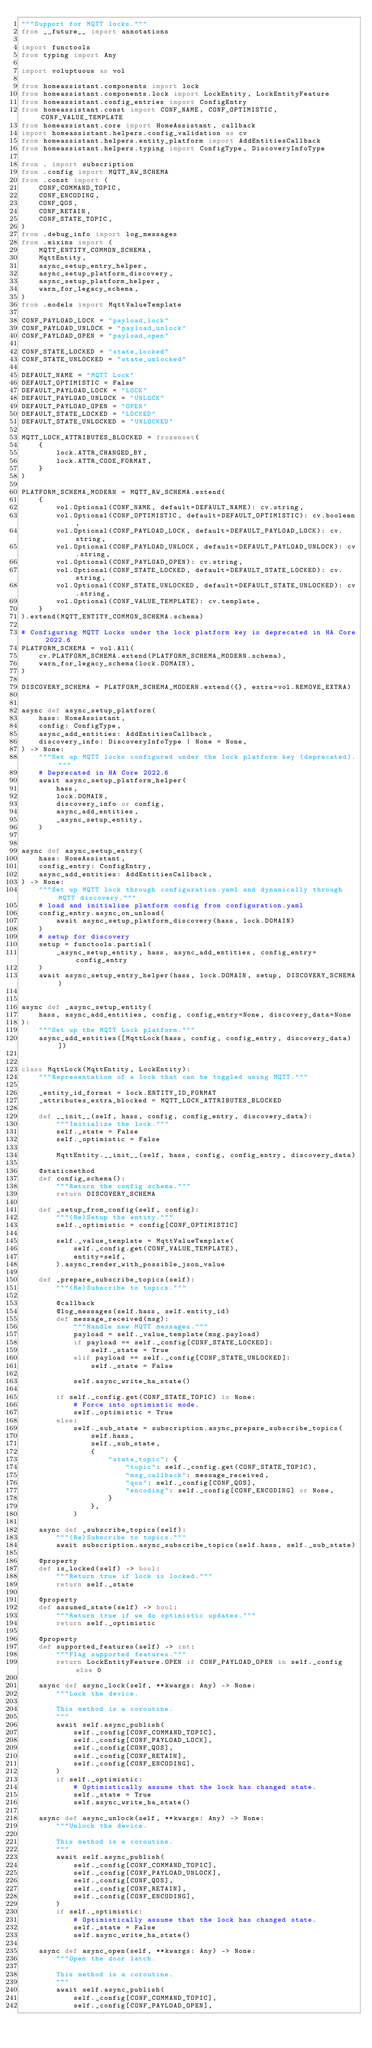Convert code to text. <code><loc_0><loc_0><loc_500><loc_500><_Python_>"""Support for MQTT locks."""
from __future__ import annotations

import functools
from typing import Any

import voluptuous as vol

from homeassistant.components import lock
from homeassistant.components.lock import LockEntity, LockEntityFeature
from homeassistant.config_entries import ConfigEntry
from homeassistant.const import CONF_NAME, CONF_OPTIMISTIC, CONF_VALUE_TEMPLATE
from homeassistant.core import HomeAssistant, callback
import homeassistant.helpers.config_validation as cv
from homeassistant.helpers.entity_platform import AddEntitiesCallback
from homeassistant.helpers.typing import ConfigType, DiscoveryInfoType

from . import subscription
from .config import MQTT_RW_SCHEMA
from .const import (
    CONF_COMMAND_TOPIC,
    CONF_ENCODING,
    CONF_QOS,
    CONF_RETAIN,
    CONF_STATE_TOPIC,
)
from .debug_info import log_messages
from .mixins import (
    MQTT_ENTITY_COMMON_SCHEMA,
    MqttEntity,
    async_setup_entry_helper,
    async_setup_platform_discovery,
    async_setup_platform_helper,
    warn_for_legacy_schema,
)
from .models import MqttValueTemplate

CONF_PAYLOAD_LOCK = "payload_lock"
CONF_PAYLOAD_UNLOCK = "payload_unlock"
CONF_PAYLOAD_OPEN = "payload_open"

CONF_STATE_LOCKED = "state_locked"
CONF_STATE_UNLOCKED = "state_unlocked"

DEFAULT_NAME = "MQTT Lock"
DEFAULT_OPTIMISTIC = False
DEFAULT_PAYLOAD_LOCK = "LOCK"
DEFAULT_PAYLOAD_UNLOCK = "UNLOCK"
DEFAULT_PAYLOAD_OPEN = "OPEN"
DEFAULT_STATE_LOCKED = "LOCKED"
DEFAULT_STATE_UNLOCKED = "UNLOCKED"

MQTT_LOCK_ATTRIBUTES_BLOCKED = frozenset(
    {
        lock.ATTR_CHANGED_BY,
        lock.ATTR_CODE_FORMAT,
    }
)

PLATFORM_SCHEMA_MODERN = MQTT_RW_SCHEMA.extend(
    {
        vol.Optional(CONF_NAME, default=DEFAULT_NAME): cv.string,
        vol.Optional(CONF_OPTIMISTIC, default=DEFAULT_OPTIMISTIC): cv.boolean,
        vol.Optional(CONF_PAYLOAD_LOCK, default=DEFAULT_PAYLOAD_LOCK): cv.string,
        vol.Optional(CONF_PAYLOAD_UNLOCK, default=DEFAULT_PAYLOAD_UNLOCK): cv.string,
        vol.Optional(CONF_PAYLOAD_OPEN): cv.string,
        vol.Optional(CONF_STATE_LOCKED, default=DEFAULT_STATE_LOCKED): cv.string,
        vol.Optional(CONF_STATE_UNLOCKED, default=DEFAULT_STATE_UNLOCKED): cv.string,
        vol.Optional(CONF_VALUE_TEMPLATE): cv.template,
    }
).extend(MQTT_ENTITY_COMMON_SCHEMA.schema)

# Configuring MQTT Locks under the lock platform key is deprecated in HA Core 2022.6
PLATFORM_SCHEMA = vol.All(
    cv.PLATFORM_SCHEMA.extend(PLATFORM_SCHEMA_MODERN.schema),
    warn_for_legacy_schema(lock.DOMAIN),
)

DISCOVERY_SCHEMA = PLATFORM_SCHEMA_MODERN.extend({}, extra=vol.REMOVE_EXTRA)


async def async_setup_platform(
    hass: HomeAssistant,
    config: ConfigType,
    async_add_entities: AddEntitiesCallback,
    discovery_info: DiscoveryInfoType | None = None,
) -> None:
    """Set up MQTT locks configured under the lock platform key (deprecated)."""
    # Deprecated in HA Core 2022.6
    await async_setup_platform_helper(
        hass,
        lock.DOMAIN,
        discovery_info or config,
        async_add_entities,
        _async_setup_entity,
    )


async def async_setup_entry(
    hass: HomeAssistant,
    config_entry: ConfigEntry,
    async_add_entities: AddEntitiesCallback,
) -> None:
    """Set up MQTT lock through configuration.yaml and dynamically through MQTT discovery."""
    # load and initialize platform config from configuration.yaml
    config_entry.async_on_unload(
        await async_setup_platform_discovery(hass, lock.DOMAIN)
    )
    # setup for discovery
    setup = functools.partial(
        _async_setup_entity, hass, async_add_entities, config_entry=config_entry
    )
    await async_setup_entry_helper(hass, lock.DOMAIN, setup, DISCOVERY_SCHEMA)


async def _async_setup_entity(
    hass, async_add_entities, config, config_entry=None, discovery_data=None
):
    """Set up the MQTT Lock platform."""
    async_add_entities([MqttLock(hass, config, config_entry, discovery_data)])


class MqttLock(MqttEntity, LockEntity):
    """Representation of a lock that can be toggled using MQTT."""

    _entity_id_format = lock.ENTITY_ID_FORMAT
    _attributes_extra_blocked = MQTT_LOCK_ATTRIBUTES_BLOCKED

    def __init__(self, hass, config, config_entry, discovery_data):
        """Initialize the lock."""
        self._state = False
        self._optimistic = False

        MqttEntity.__init__(self, hass, config, config_entry, discovery_data)

    @staticmethod
    def config_schema():
        """Return the config schema."""
        return DISCOVERY_SCHEMA

    def _setup_from_config(self, config):
        """(Re)Setup the entity."""
        self._optimistic = config[CONF_OPTIMISTIC]

        self._value_template = MqttValueTemplate(
            self._config.get(CONF_VALUE_TEMPLATE),
            entity=self,
        ).async_render_with_possible_json_value

    def _prepare_subscribe_topics(self):
        """(Re)Subscribe to topics."""

        @callback
        @log_messages(self.hass, self.entity_id)
        def message_received(msg):
            """Handle new MQTT messages."""
            payload = self._value_template(msg.payload)
            if payload == self._config[CONF_STATE_LOCKED]:
                self._state = True
            elif payload == self._config[CONF_STATE_UNLOCKED]:
                self._state = False

            self.async_write_ha_state()

        if self._config.get(CONF_STATE_TOPIC) is None:
            # Force into optimistic mode.
            self._optimistic = True
        else:
            self._sub_state = subscription.async_prepare_subscribe_topics(
                self.hass,
                self._sub_state,
                {
                    "state_topic": {
                        "topic": self._config.get(CONF_STATE_TOPIC),
                        "msg_callback": message_received,
                        "qos": self._config[CONF_QOS],
                        "encoding": self._config[CONF_ENCODING] or None,
                    }
                },
            )

    async def _subscribe_topics(self):
        """(Re)Subscribe to topics."""
        await subscription.async_subscribe_topics(self.hass, self._sub_state)

    @property
    def is_locked(self) -> bool:
        """Return true if lock is locked."""
        return self._state

    @property
    def assumed_state(self) -> bool:
        """Return true if we do optimistic updates."""
        return self._optimistic

    @property
    def supported_features(self) -> int:
        """Flag supported features."""
        return LockEntityFeature.OPEN if CONF_PAYLOAD_OPEN in self._config else 0

    async def async_lock(self, **kwargs: Any) -> None:
        """Lock the device.

        This method is a coroutine.
        """
        await self.async_publish(
            self._config[CONF_COMMAND_TOPIC],
            self._config[CONF_PAYLOAD_LOCK],
            self._config[CONF_QOS],
            self._config[CONF_RETAIN],
            self._config[CONF_ENCODING],
        )
        if self._optimistic:
            # Optimistically assume that the lock has changed state.
            self._state = True
            self.async_write_ha_state()

    async def async_unlock(self, **kwargs: Any) -> None:
        """Unlock the device.

        This method is a coroutine.
        """
        await self.async_publish(
            self._config[CONF_COMMAND_TOPIC],
            self._config[CONF_PAYLOAD_UNLOCK],
            self._config[CONF_QOS],
            self._config[CONF_RETAIN],
            self._config[CONF_ENCODING],
        )
        if self._optimistic:
            # Optimistically assume that the lock has changed state.
            self._state = False
            self.async_write_ha_state()

    async def async_open(self, **kwargs: Any) -> None:
        """Open the door latch.

        This method is a coroutine.
        """
        await self.async_publish(
            self._config[CONF_COMMAND_TOPIC],
            self._config[CONF_PAYLOAD_OPEN],</code> 